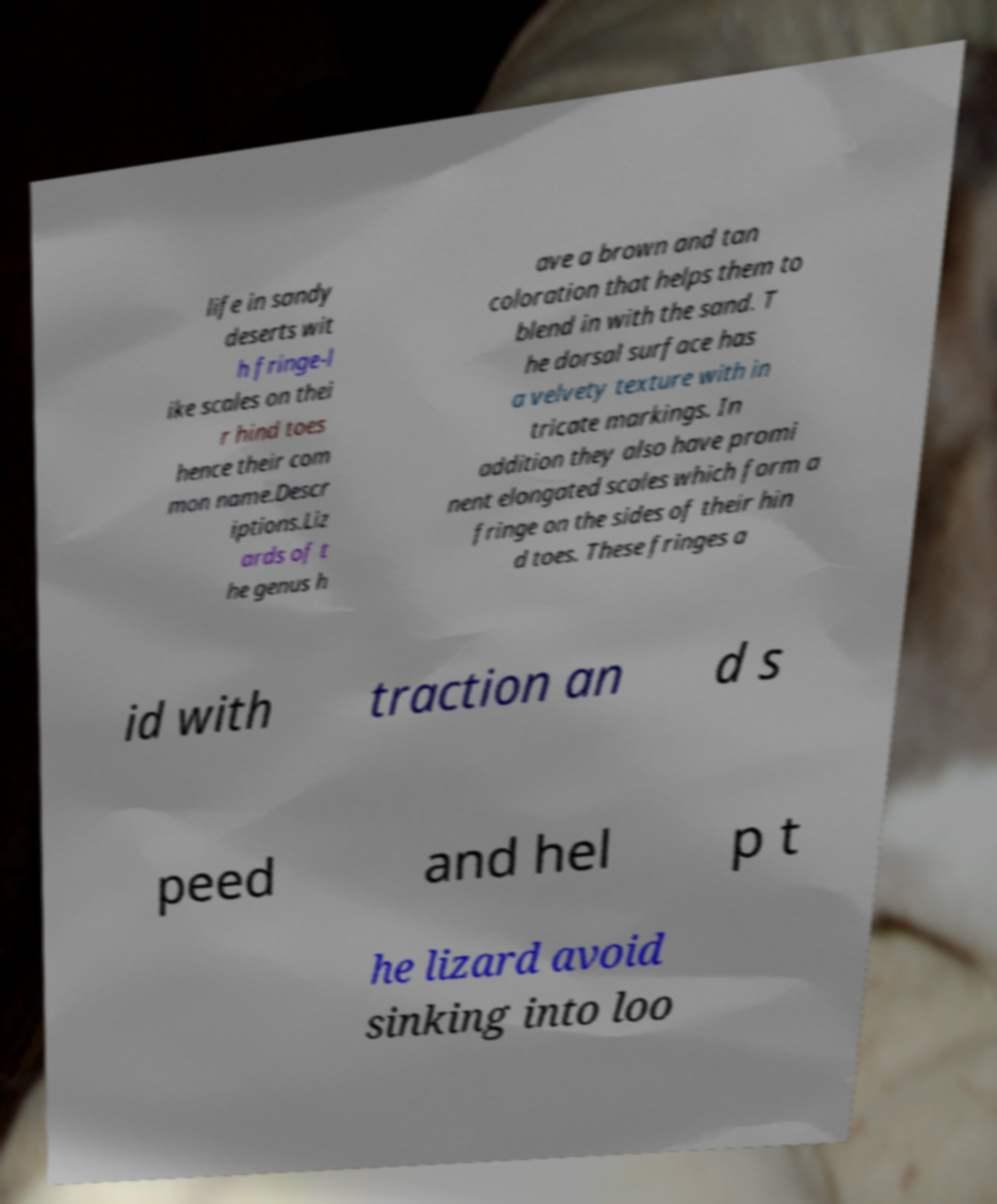I need the written content from this picture converted into text. Can you do that? life in sandy deserts wit h fringe-l ike scales on thei r hind toes hence their com mon name.Descr iptions.Liz ards of t he genus h ave a brown and tan coloration that helps them to blend in with the sand. T he dorsal surface has a velvety texture with in tricate markings. In addition they also have promi nent elongated scales which form a fringe on the sides of their hin d toes. These fringes a id with traction an d s peed and hel p t he lizard avoid sinking into loo 